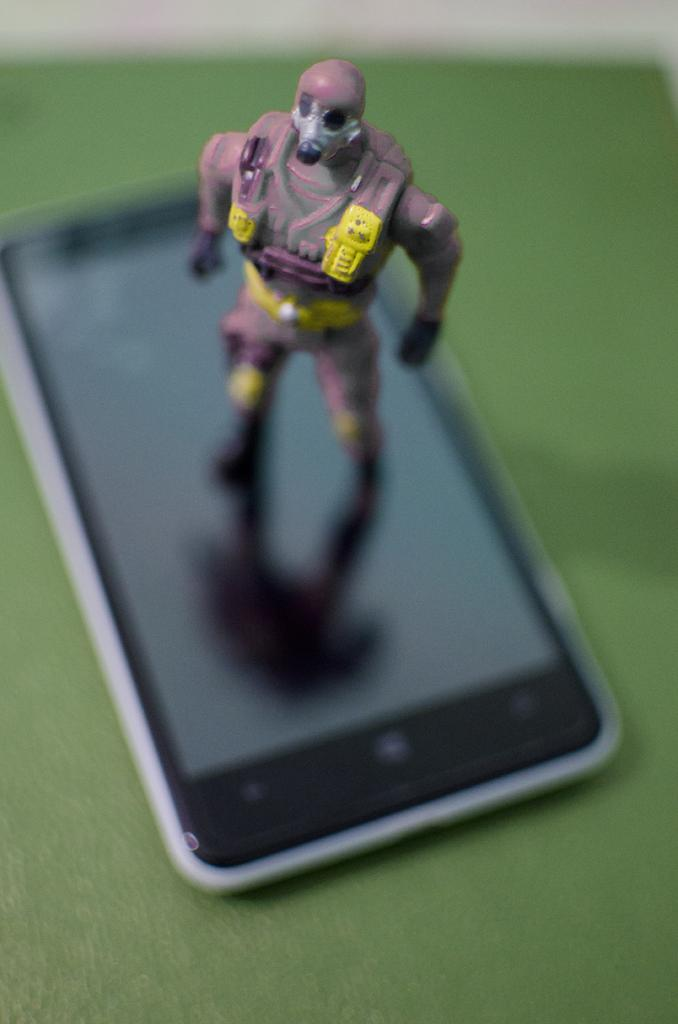What electronic device is visible in the picture? There is a mobile phone in the picture. What is displayed on the mobile phone's screen? There is a toy displayed on the mobile phone's screen. What type of toothbrush is shown in the picture? There is no toothbrush present in the picture; it features a mobile phone with a toy displayed on its screen. 